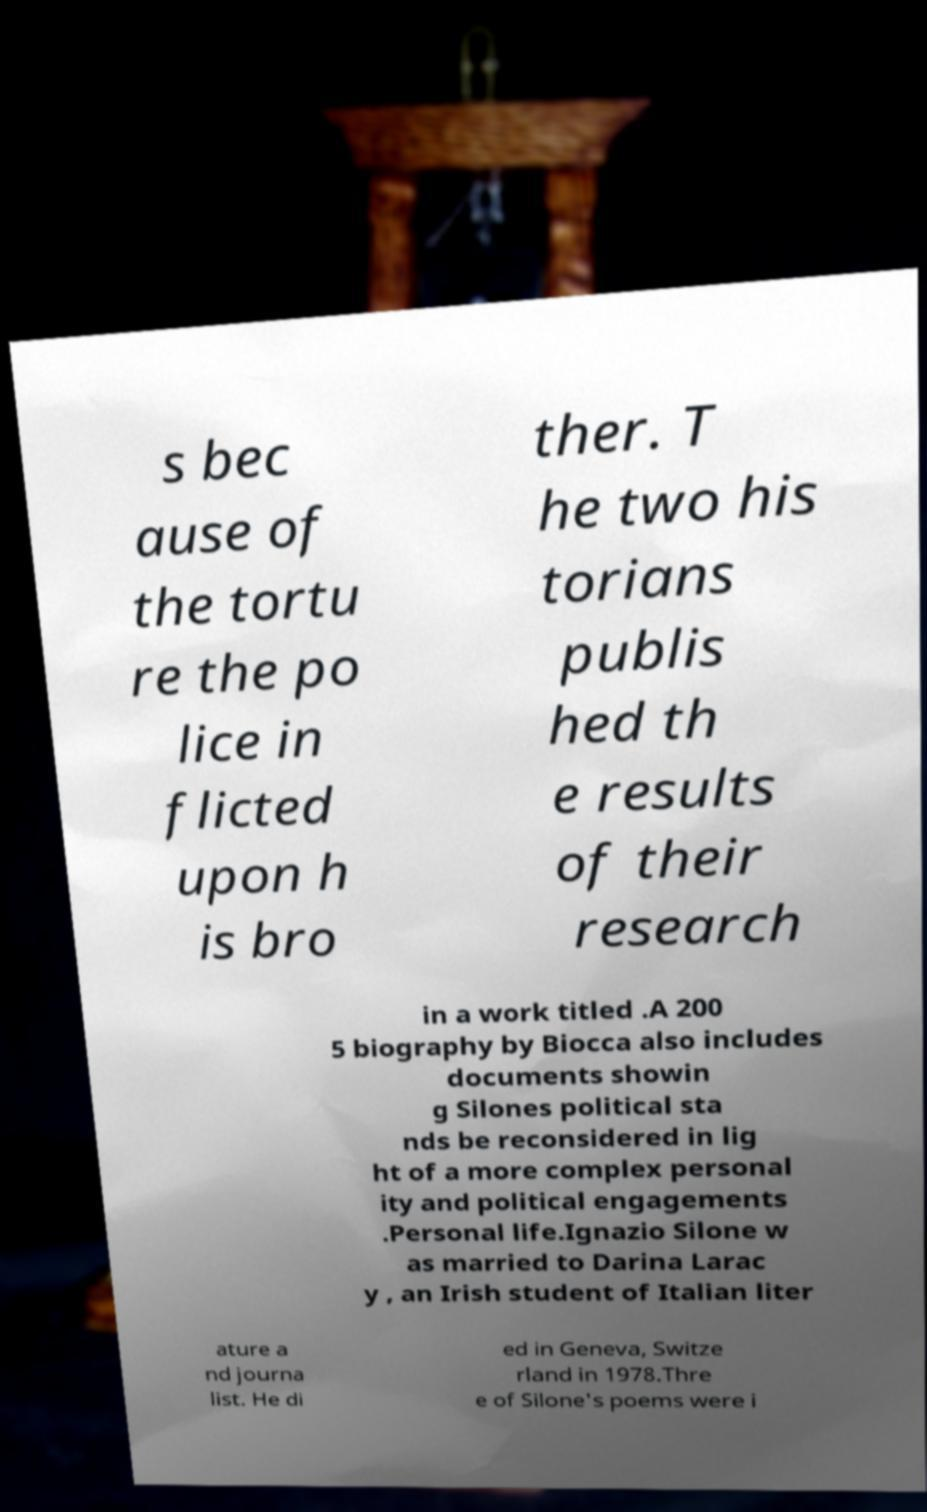Can you accurately transcribe the text from the provided image for me? s bec ause of the tortu re the po lice in flicted upon h is bro ther. T he two his torians publis hed th e results of their research in a work titled .A 200 5 biography by Biocca also includes documents showin g Silones political sta nds be reconsidered in lig ht of a more complex personal ity and political engagements .Personal life.Ignazio Silone w as married to Darina Larac y , an Irish student of Italian liter ature a nd journa list. He di ed in Geneva, Switze rland in 1978.Thre e of Silone's poems were i 